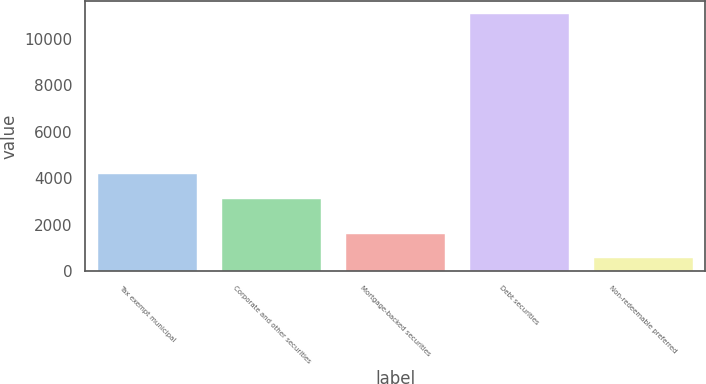Convert chart to OTSL. <chart><loc_0><loc_0><loc_500><loc_500><bar_chart><fcel>Tax exempt municipal<fcel>Corporate and other securities<fcel>Mortgage-backed securities<fcel>Debt securities<fcel>Non-redeemable preferred<nl><fcel>4171.6<fcel>3121<fcel>1619.6<fcel>11075<fcel>569<nl></chart> 